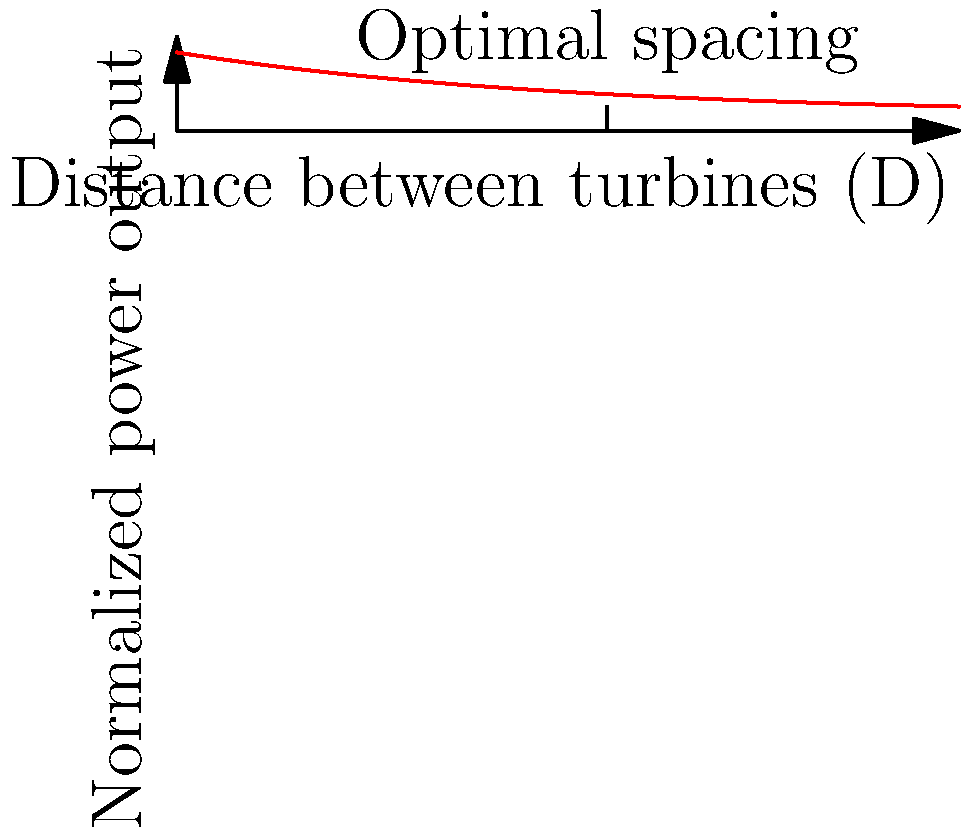In a wind farm layout, the power output of wind turbines is affected by their spacing due to wake effects. Given the graph showing normalized power output versus turbine spacing (in rotor diameters D), what is the optimal spacing between turbines to maximize power output while minimizing land use? To determine the optimal spacing between wind turbines, we need to analyze the graph:

1. The x-axis represents the distance between turbines in rotor diameters (D).
2. The y-axis shows the normalized power output.
3. The curve represents how power output changes with turbine spacing.

To find the optimal spacing, we look for the point where:
a) The power output is maximized
b) Further increases in spacing yield diminishing returns

Analyzing the graph:
1. Power output increases rapidly from 0D to about 5D spacing.
2. After 5D, the curve begins to flatten, indicating diminishing returns.
3. The "knee" of the curve, where the rate of increase significantly slows, occurs around 5-6D.

The optimal spacing is at this "knee" point, approximately 5.5D. This balances:
- Maximizing power output (close to peak efficiency)
- Minimizing land use (avoiding unnecessary spacing)
- Considering economic factors (diminishing returns beyond this point)

This spacing allows for good wake recovery while efficiently utilizing land area.
Answer: 5.5 rotor diameters (5.5D) 